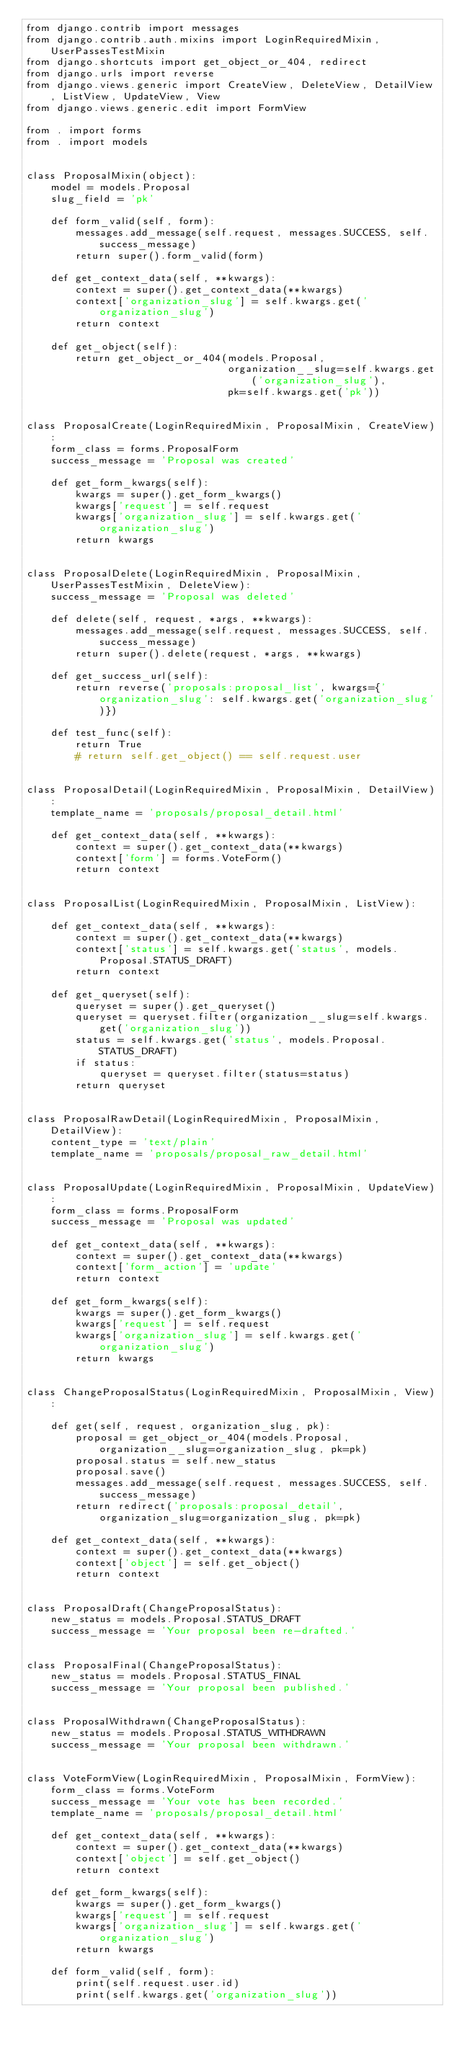Convert code to text. <code><loc_0><loc_0><loc_500><loc_500><_Python_>from django.contrib import messages
from django.contrib.auth.mixins import LoginRequiredMixin, UserPassesTestMixin
from django.shortcuts import get_object_or_404, redirect
from django.urls import reverse
from django.views.generic import CreateView, DeleteView, DetailView, ListView, UpdateView, View
from django.views.generic.edit import FormView

from . import forms
from . import models


class ProposalMixin(object):
    model = models.Proposal
    slug_field = 'pk'

    def form_valid(self, form):
        messages.add_message(self.request, messages.SUCCESS, self.success_message)
        return super().form_valid(form)

    def get_context_data(self, **kwargs):
        context = super().get_context_data(**kwargs)
        context['organization_slug'] = self.kwargs.get('organization_slug')
        return context

    def get_object(self):
        return get_object_or_404(models.Proposal,
                                 organization__slug=self.kwargs.get('organization_slug'),
                                 pk=self.kwargs.get('pk'))


class ProposalCreate(LoginRequiredMixin, ProposalMixin, CreateView):
    form_class = forms.ProposalForm
    success_message = 'Proposal was created'

    def get_form_kwargs(self):
        kwargs = super().get_form_kwargs()
        kwargs['request'] = self.request
        kwargs['organization_slug'] = self.kwargs.get('organization_slug')
        return kwargs


class ProposalDelete(LoginRequiredMixin, ProposalMixin, UserPassesTestMixin, DeleteView):
    success_message = 'Proposal was deleted'

    def delete(self, request, *args, **kwargs):
        messages.add_message(self.request, messages.SUCCESS, self.success_message)
        return super().delete(request, *args, **kwargs)

    def get_success_url(self):
        return reverse('proposals:proposal_list', kwargs={'organization_slug': self.kwargs.get('organization_slug')})

    def test_func(self):
        return True
        # return self.get_object() == self.request.user


class ProposalDetail(LoginRequiredMixin, ProposalMixin, DetailView):
    template_name = 'proposals/proposal_detail.html'

    def get_context_data(self, **kwargs):
        context = super().get_context_data(**kwargs)
        context['form'] = forms.VoteForm()
        return context


class ProposalList(LoginRequiredMixin, ProposalMixin, ListView):

    def get_context_data(self, **kwargs):
        context = super().get_context_data(**kwargs)
        context['status'] = self.kwargs.get('status', models.Proposal.STATUS_DRAFT)
        return context

    def get_queryset(self):
        queryset = super().get_queryset()
        queryset = queryset.filter(organization__slug=self.kwargs.get('organization_slug'))
        status = self.kwargs.get('status', models.Proposal.STATUS_DRAFT)
        if status:
            queryset = queryset.filter(status=status)
        return queryset


class ProposalRawDetail(LoginRequiredMixin, ProposalMixin, DetailView):
    content_type = 'text/plain'
    template_name = 'proposals/proposal_raw_detail.html'


class ProposalUpdate(LoginRequiredMixin, ProposalMixin, UpdateView):
    form_class = forms.ProposalForm
    success_message = 'Proposal was updated'

    def get_context_data(self, **kwargs):
        context = super().get_context_data(**kwargs)
        context['form_action'] = 'update'
        return context

    def get_form_kwargs(self):
        kwargs = super().get_form_kwargs()
        kwargs['request'] = self.request
        kwargs['organization_slug'] = self.kwargs.get('organization_slug')
        return kwargs


class ChangeProposalStatus(LoginRequiredMixin, ProposalMixin, View):

    def get(self, request, organization_slug, pk):
        proposal = get_object_or_404(models.Proposal, organization__slug=organization_slug, pk=pk)
        proposal.status = self.new_status
        proposal.save()
        messages.add_message(self.request, messages.SUCCESS, self.success_message)
        return redirect('proposals:proposal_detail', organization_slug=organization_slug, pk=pk)

    def get_context_data(self, **kwargs):
        context = super().get_context_data(**kwargs)
        context['object'] = self.get_object()
        return context


class ProposalDraft(ChangeProposalStatus):
    new_status = models.Proposal.STATUS_DRAFT
    success_message = 'Your proposal been re-drafted.'


class ProposalFinal(ChangeProposalStatus):
    new_status = models.Proposal.STATUS_FINAL
    success_message = 'Your proposal been published.'


class ProposalWithdrawn(ChangeProposalStatus):
    new_status = models.Proposal.STATUS_WITHDRAWN
    success_message = 'Your proposal been withdrawn.'


class VoteFormView(LoginRequiredMixin, ProposalMixin, FormView):
    form_class = forms.VoteForm
    success_message = 'Your vote has been recorded.'
    template_name = 'proposals/proposal_detail.html'

    def get_context_data(self, **kwargs):
        context = super().get_context_data(**kwargs)
        context['object'] = self.get_object()
        return context

    def get_form_kwargs(self):
        kwargs = super().get_form_kwargs()
        kwargs['request'] = self.request
        kwargs['organization_slug'] = self.kwargs.get('organization_slug')
        return kwargs

    def form_valid(self, form):
        print(self.request.user.id)
        print(self.kwargs.get('organization_slug'))</code> 